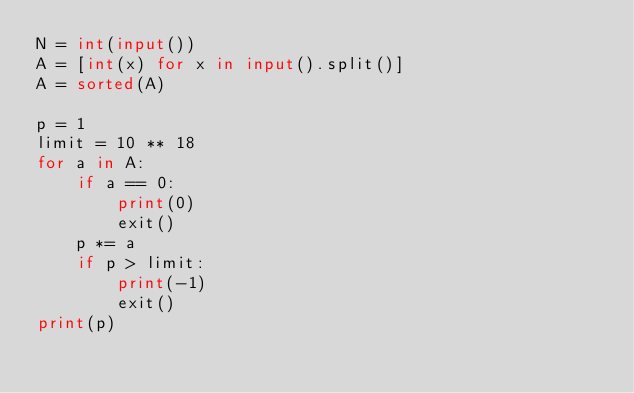<code> <loc_0><loc_0><loc_500><loc_500><_Python_>N = int(input())
A = [int(x) for x in input().split()]
A = sorted(A)

p = 1
limit = 10 ** 18
for a in A:
    if a == 0:
        print(0)
        exit()
    p *= a
    if p > limit:
        print(-1)
        exit()
print(p)
</code> 